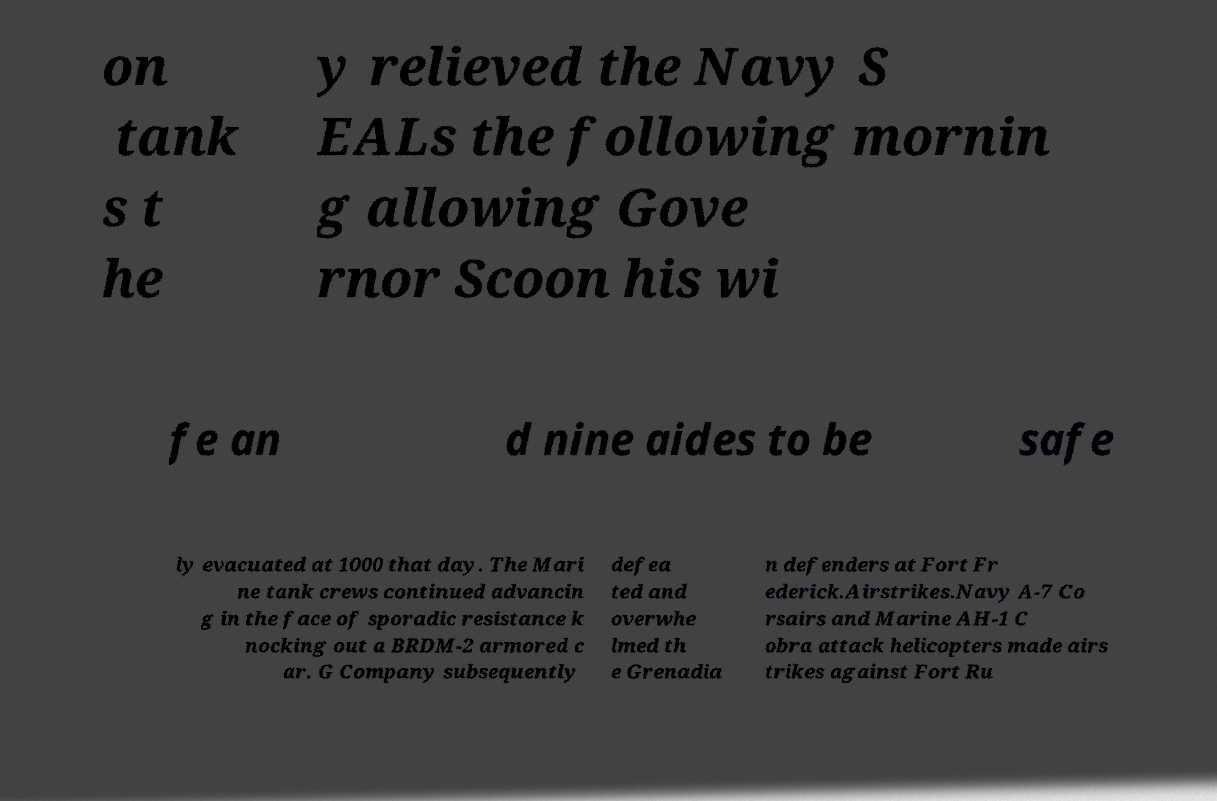Could you assist in decoding the text presented in this image and type it out clearly? on tank s t he y relieved the Navy S EALs the following mornin g allowing Gove rnor Scoon his wi fe an d nine aides to be safe ly evacuated at 1000 that day. The Mari ne tank crews continued advancin g in the face of sporadic resistance k nocking out a BRDM-2 armored c ar. G Company subsequently defea ted and overwhe lmed th e Grenadia n defenders at Fort Fr ederick.Airstrikes.Navy A-7 Co rsairs and Marine AH-1 C obra attack helicopters made airs trikes against Fort Ru 